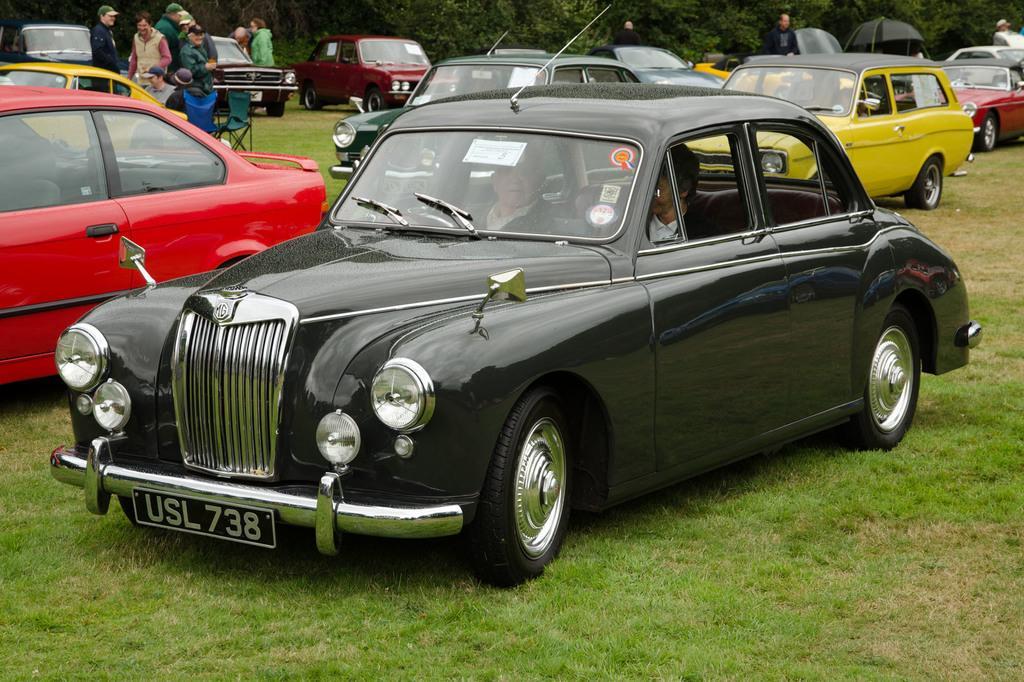Could you give a brief overview of what you see in this image? In this image we can see some vehicles and people on the ground, among them some are sitting on the chairs and some are sitting in the vehicles, in the background we can see some trees. 